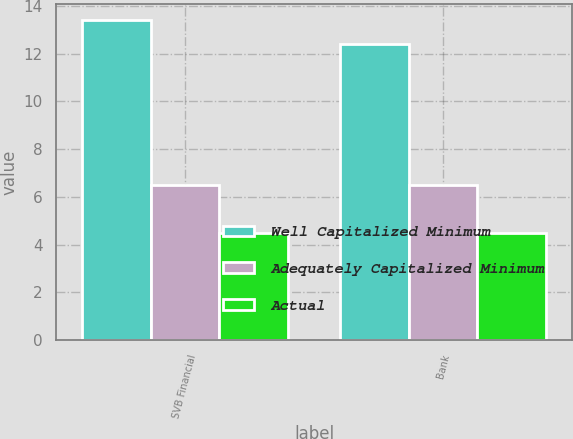Convert chart. <chart><loc_0><loc_0><loc_500><loc_500><stacked_bar_chart><ecel><fcel>SVB Financial<fcel>Bank<nl><fcel>Well Capitalized Minimum<fcel>13.41<fcel>12.41<nl><fcel>Adequately Capitalized Minimum<fcel>6.5<fcel>6.5<nl><fcel>Actual<fcel>4.5<fcel>4.5<nl></chart> 